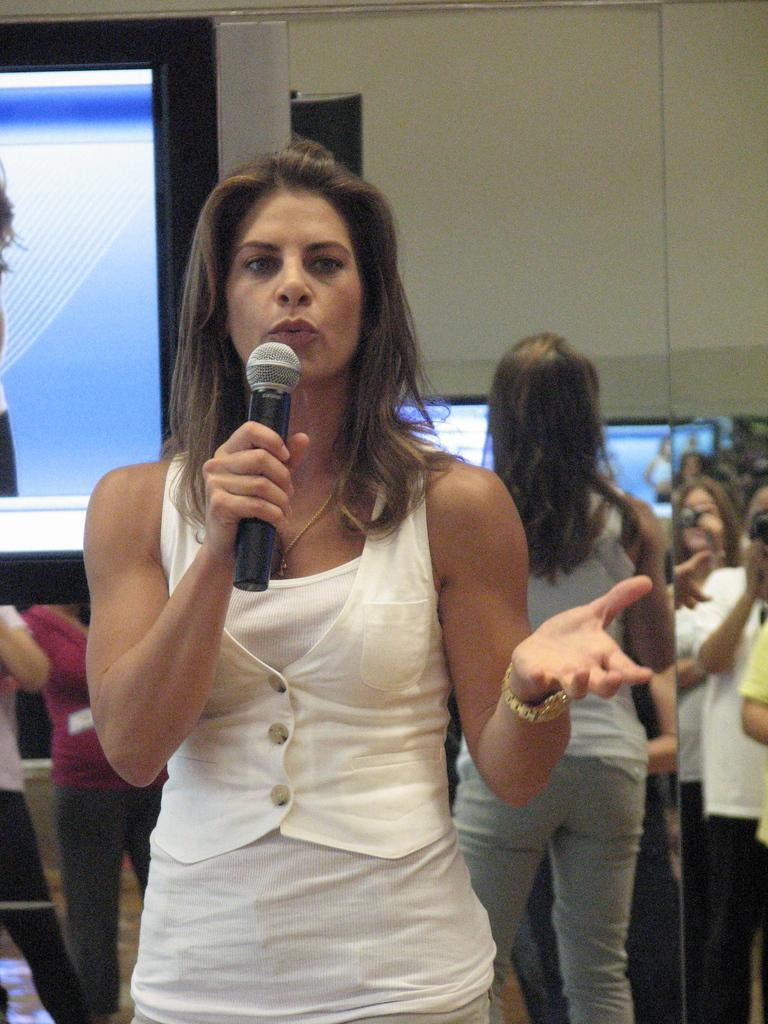What is the person in the image doing? The person in the image is speaking. What is the person holding while speaking? The person is holding a microphone. Are there any other people visible in the image? Yes, there are other people standing behind the speaker. What can be seen in the left corner of the image? There is a television (T.V.) in the left corner of the image. How many fish are swimming on top of the speaker in the image? There are no fish present in the image, and therefore no fish can be seen swimming on top of the speaker. 